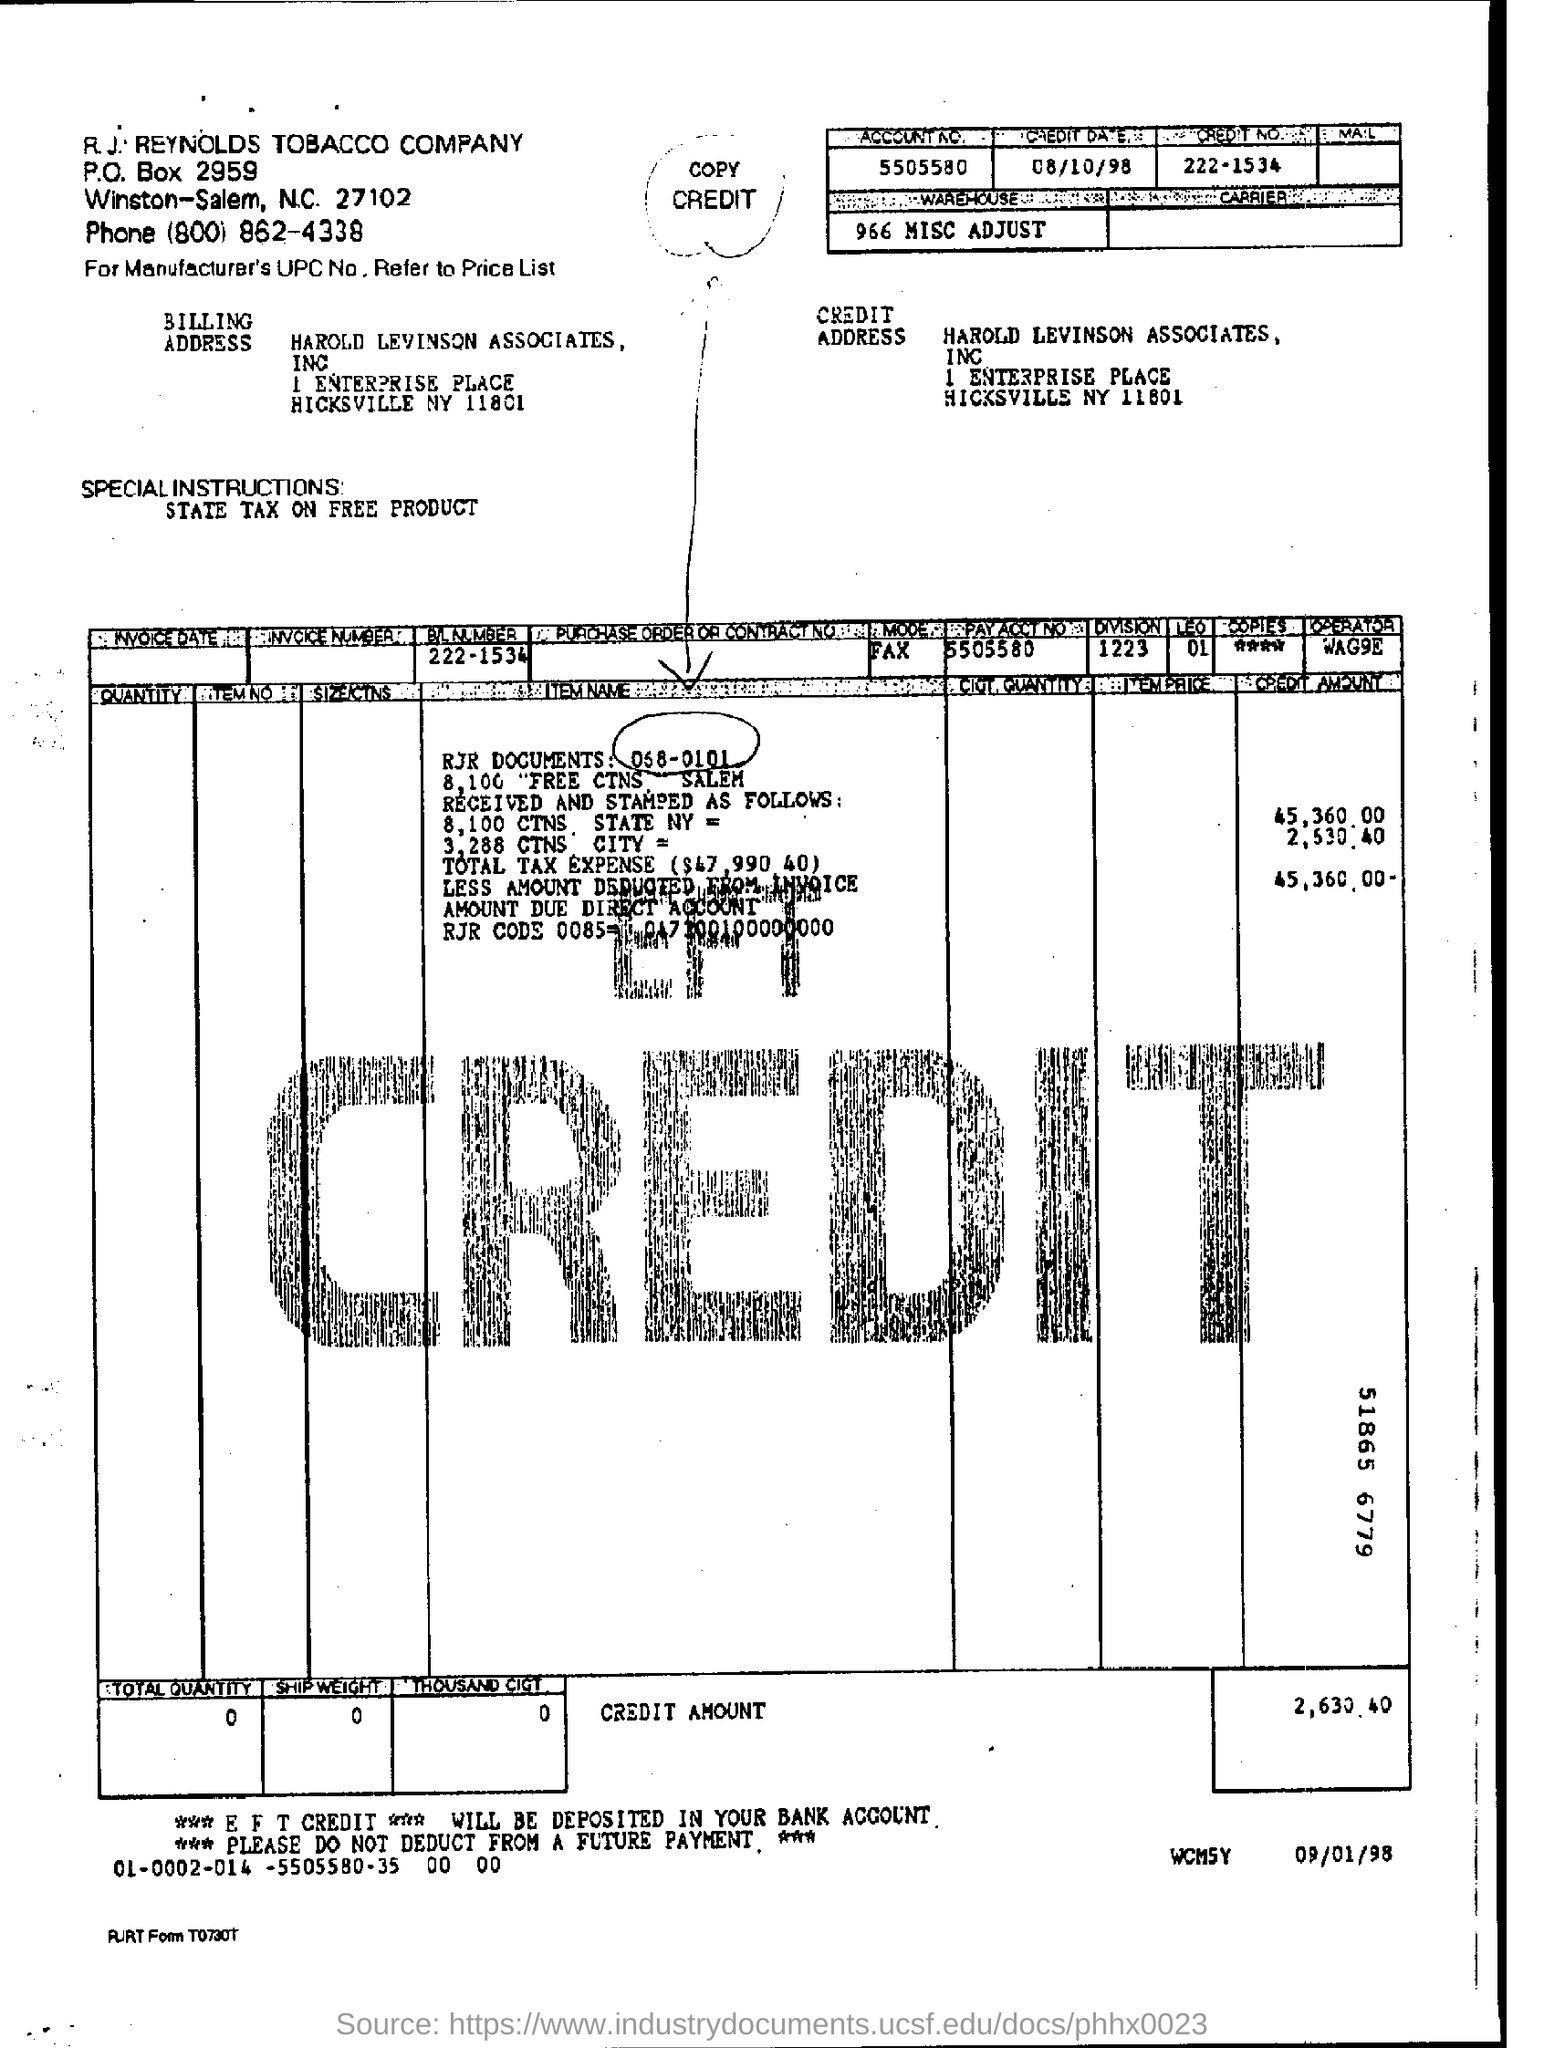What is the zipcode of harold  levinson associates, inc ?
Provide a short and direct response. 11801. Mention the credit date ?
Offer a terse response. 08/10/98. What is the pay acct no. ?
Give a very brief answer. 5505580. 